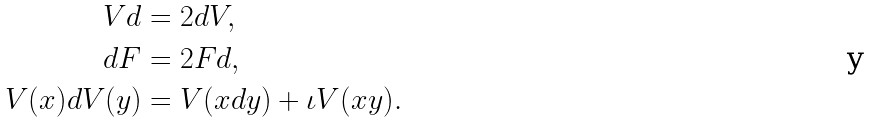<formula> <loc_0><loc_0><loc_500><loc_500>V d & = 2 d V , \\ d F & = 2 F d , \\ V ( x ) d V ( y ) & = V ( x d y ) + \iota V ( x y ) .</formula> 